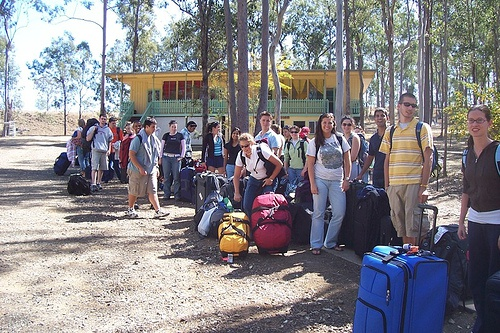Describe the objects in this image and their specific colors. I can see suitcase in lightblue, navy, darkblue, blue, and black tones, people in lightblue, black, gray, darkgray, and lightgray tones, people in lightblue, black, and gray tones, people in lightblue, gray, tan, and darkgray tones, and people in lightblue, gray, darkgray, and black tones in this image. 